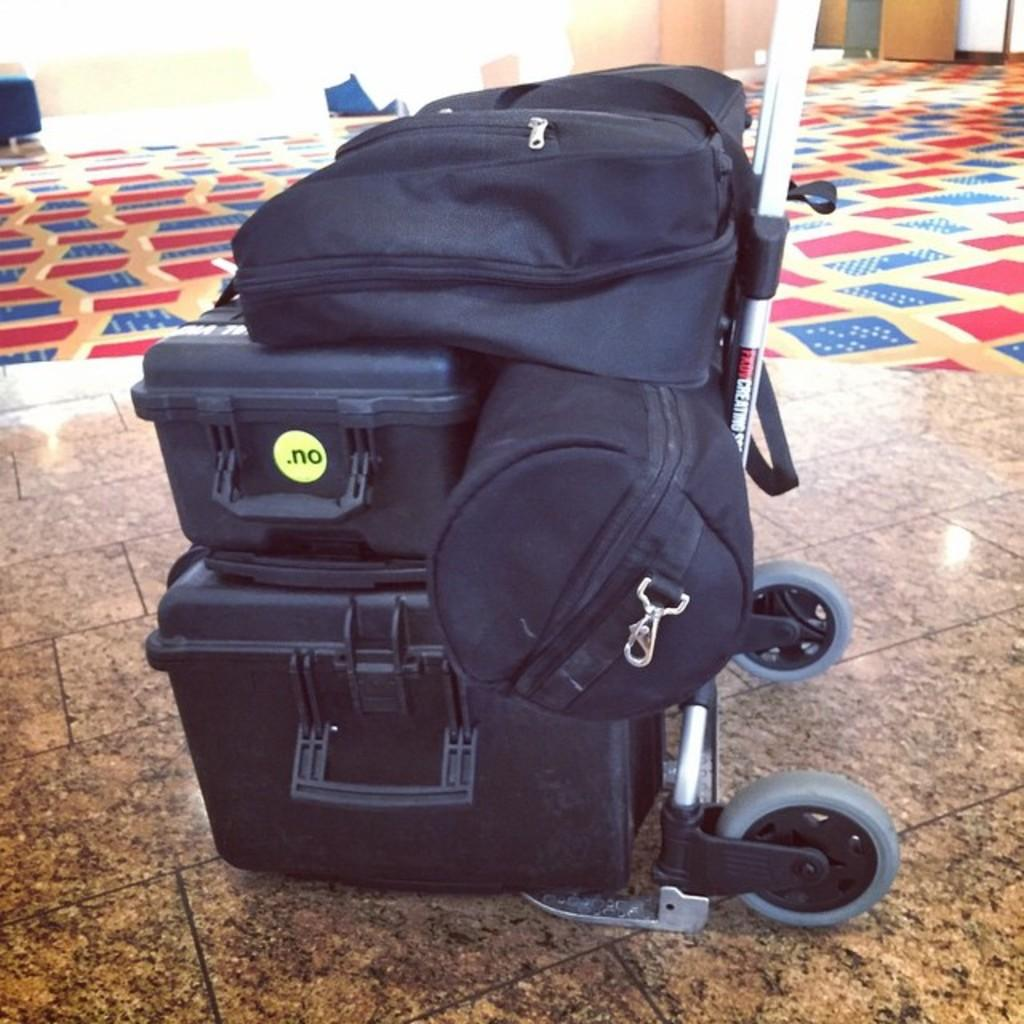What is the main object in the middle of the image? There is a bag in the middle of the image. What is the color of the bag? The bag is black in color. Is there any other black object on the bag? Yes, there is a black color box on the bag. What can be seen in the background of the image? There is a red color carpet in the background of the image. What historical event is being discussed on the news in the image? There is no news or discussion of historical events present in the image; it features a bag with a black color box on it and a red color carpet in the background. 